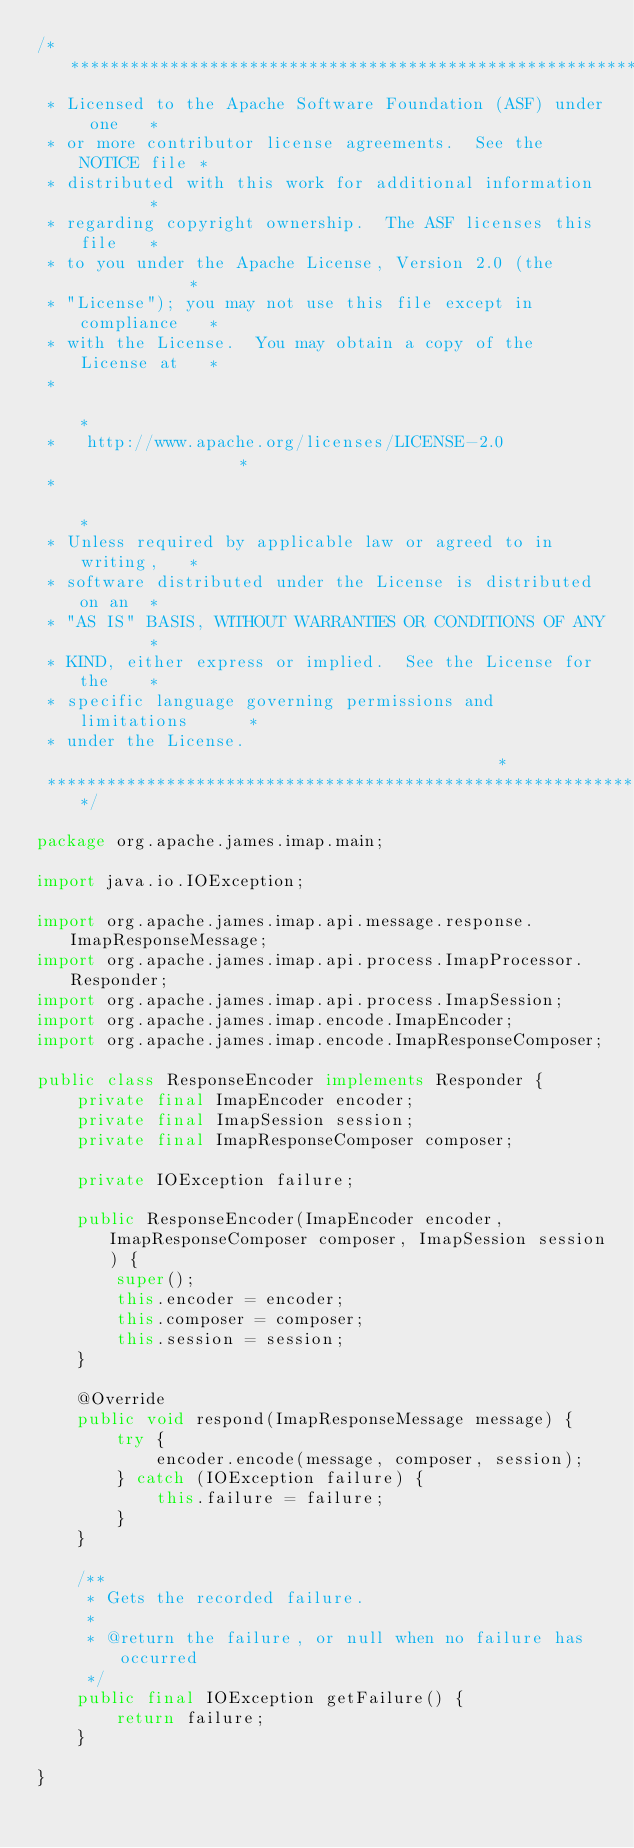<code> <loc_0><loc_0><loc_500><loc_500><_Java_>/****************************************************************
 * Licensed to the Apache Software Foundation (ASF) under one   *
 * or more contributor license agreements.  See the NOTICE file *
 * distributed with this work for additional information        *
 * regarding copyright ownership.  The ASF licenses this file   *
 * to you under the Apache License, Version 2.0 (the            *
 * "License"); you may not use this file except in compliance   *
 * with the License.  You may obtain a copy of the License at   *
 *                                                              *
 *   http://www.apache.org/licenses/LICENSE-2.0                 *
 *                                                              *
 * Unless required by applicable law or agreed to in writing,   *
 * software distributed under the License is distributed on an  *
 * "AS IS" BASIS, WITHOUT WARRANTIES OR CONDITIONS OF ANY       *
 * KIND, either express or implied.  See the License for the    *
 * specific language governing permissions and limitations      *
 * under the License.                                           *
 ****************************************************************/

package org.apache.james.imap.main;

import java.io.IOException;

import org.apache.james.imap.api.message.response.ImapResponseMessage;
import org.apache.james.imap.api.process.ImapProcessor.Responder;
import org.apache.james.imap.api.process.ImapSession;
import org.apache.james.imap.encode.ImapEncoder;
import org.apache.james.imap.encode.ImapResponseComposer;

public class ResponseEncoder implements Responder {
    private final ImapEncoder encoder;
    private final ImapSession session;
    private final ImapResponseComposer composer;

    private IOException failure;

    public ResponseEncoder(ImapEncoder encoder, ImapResponseComposer composer, ImapSession session) {
        super();
        this.encoder = encoder;
        this.composer = composer;
        this.session = session;
    }

    @Override
    public void respond(ImapResponseMessage message) {
        try {
            encoder.encode(message, composer, session);
        } catch (IOException failure) {
            this.failure = failure;
        }
    }

    /**
     * Gets the recorded failure.
     * 
     * @return the failure, or null when no failure has occurred
     */
    public final IOException getFailure() {
        return failure;
    }

}
</code> 